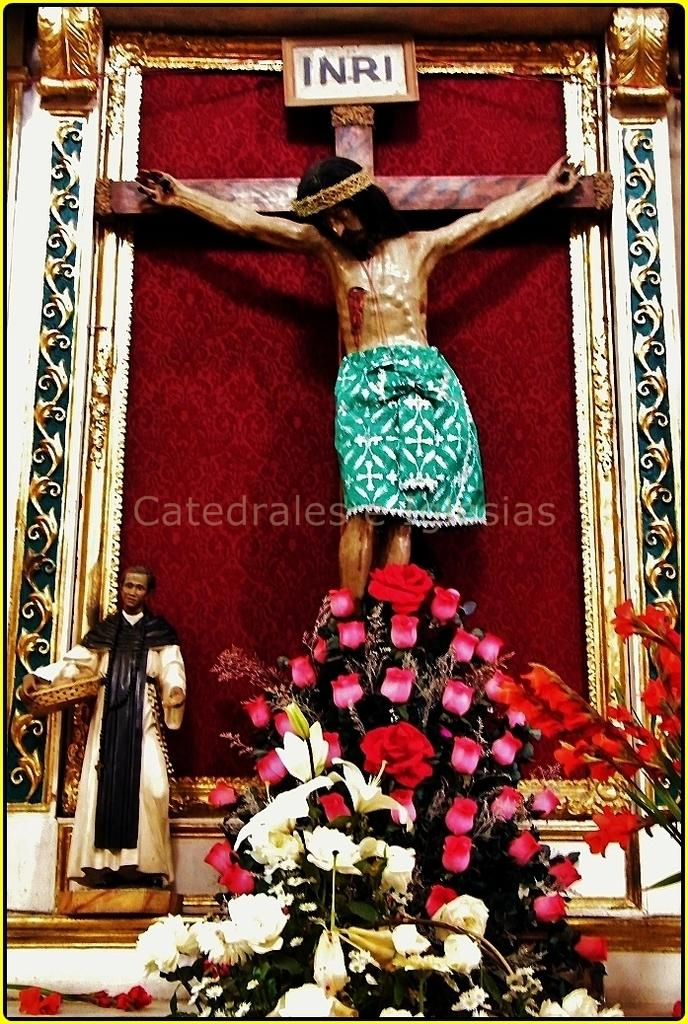What types of flowers can be seen in the image? There are different colors of flowers in the image. What other object is present in the image besides the flowers? There is a statue in the image. What is the person in the image doing? The person is holding a tray in the image. How many clocks are visible in the image? There are no clocks present in the image. What type of bucket is being used by the person holding a tray in the image? There is no bucket present in the image; the person is holding a tray. 